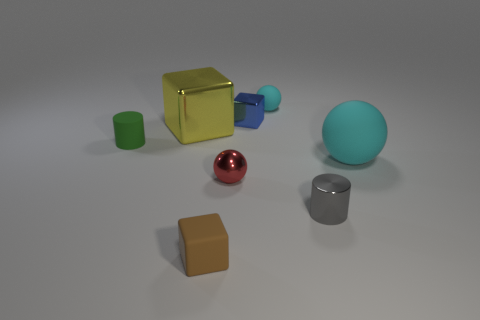Subtract all matte spheres. How many spheres are left? 1 Subtract all blocks. How many objects are left? 5 Add 1 tiny blue cubes. How many objects exist? 9 Subtract all blue blocks. How many blocks are left? 2 Subtract 0 cyan cubes. How many objects are left? 8 Subtract 1 cubes. How many cubes are left? 2 Subtract all gray cubes. Subtract all gray balls. How many cubes are left? 3 Subtract all blue cubes. How many gray cylinders are left? 1 Subtract all cylinders. Subtract all tiny rubber cubes. How many objects are left? 5 Add 7 big cyan matte things. How many big cyan matte things are left? 8 